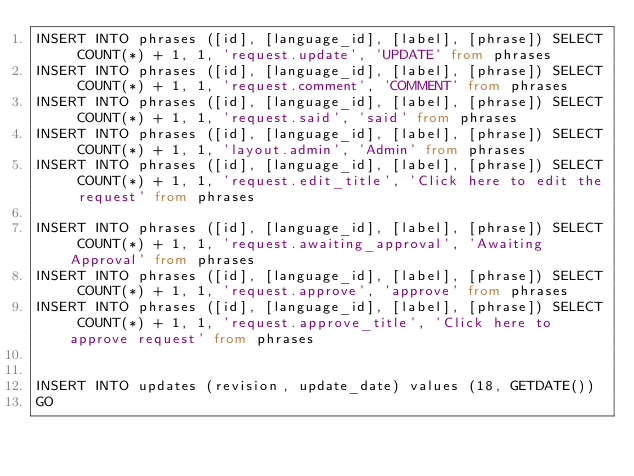Convert code to text. <code><loc_0><loc_0><loc_500><loc_500><_SQL_>INSERT INTO phrases ([id], [language_id], [label], [phrase]) SELECT COUNT(*) + 1, 1, 'request.update', 'UPDATE' from phrases
INSERT INTO phrases ([id], [language_id], [label], [phrase]) SELECT COUNT(*) + 1, 1, 'request.comment', 'COMMENT' from phrases
INSERT INTO phrases ([id], [language_id], [label], [phrase]) SELECT COUNT(*) + 1, 1, 'request.said', 'said' from phrases
INSERT INTO phrases ([id], [language_id], [label], [phrase]) SELECT COUNT(*) + 1, 1, 'layout.admin', 'Admin' from phrases
INSERT INTO phrases ([id], [language_id], [label], [phrase]) SELECT COUNT(*) + 1, 1, 'request.edit_title', 'Click here to edit the request' from phrases

INSERT INTO phrases ([id], [language_id], [label], [phrase]) SELECT COUNT(*) + 1, 1, 'request.awaiting_approval', 'Awaiting Approval' from phrases
INSERT INTO phrases ([id], [language_id], [label], [phrase]) SELECT COUNT(*) + 1, 1, 'request.approve', 'approve' from phrases
INSERT INTO phrases ([id], [language_id], [label], [phrase]) SELECT COUNT(*) + 1, 1, 'request.approve_title', 'Click here to approve request' from phrases


INSERT INTO updates (revision, update_date) values (18, GETDATE())
GO

</code> 